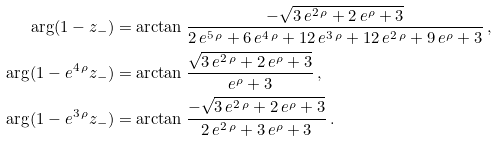<formula> <loc_0><loc_0><loc_500><loc_500>\arg ( 1 - z _ { - } ) & = \arctan \frac { { - \sqrt { 3 \, e ^ { 2 \, \rho } + 2 \, e ^ { \rho } + 3 } } } { 2 \, e ^ { 5 \, \rho } + 6 \, e ^ { 4 \, \rho } + 1 2 \, e ^ { 3 \, \rho } + 1 2 \, e ^ { 2 \, \rho } + 9 \, e ^ { \rho } + 3 } \, , \\ \arg ( 1 - e ^ { 4 \, \rho } z _ { - } ) & = \arctan \frac { { \sqrt { 3 \, e ^ { 2 \, \rho } + 2 \, e ^ { \rho } + 3 } } } { e ^ { \rho } + 3 } \, , \\ \arg ( 1 - e ^ { 3 \, \rho } z _ { - } ) & = \arctan \frac { { - \sqrt { 3 \, e ^ { 2 \, \rho } + 2 \, e ^ { \rho } + 3 } } } { 2 \, e ^ { 2 \, \rho } + 3 \, e ^ { \rho } + 3 } \, .</formula> 